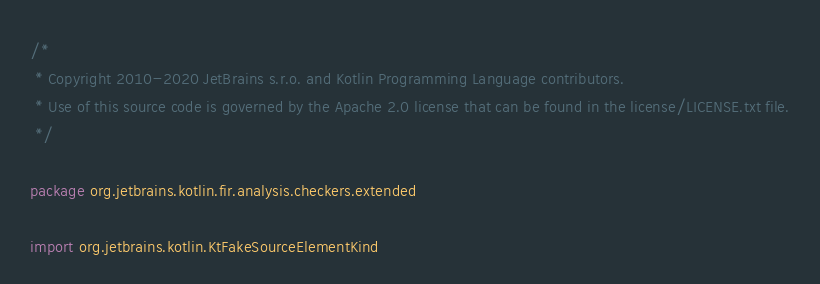Convert code to text. <code><loc_0><loc_0><loc_500><loc_500><_Kotlin_>/*
 * Copyright 2010-2020 JetBrains s.r.o. and Kotlin Programming Language contributors.
 * Use of this source code is governed by the Apache 2.0 license that can be found in the license/LICENSE.txt file.
 */

package org.jetbrains.kotlin.fir.analysis.checkers.extended

import org.jetbrains.kotlin.KtFakeSourceElementKind</code> 